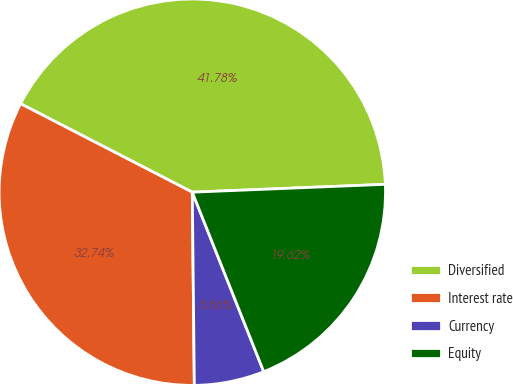<chart> <loc_0><loc_0><loc_500><loc_500><pie_chart><fcel>Diversified<fcel>Interest rate<fcel>Currency<fcel>Equity<nl><fcel>41.78%<fcel>32.74%<fcel>5.86%<fcel>19.62%<nl></chart> 